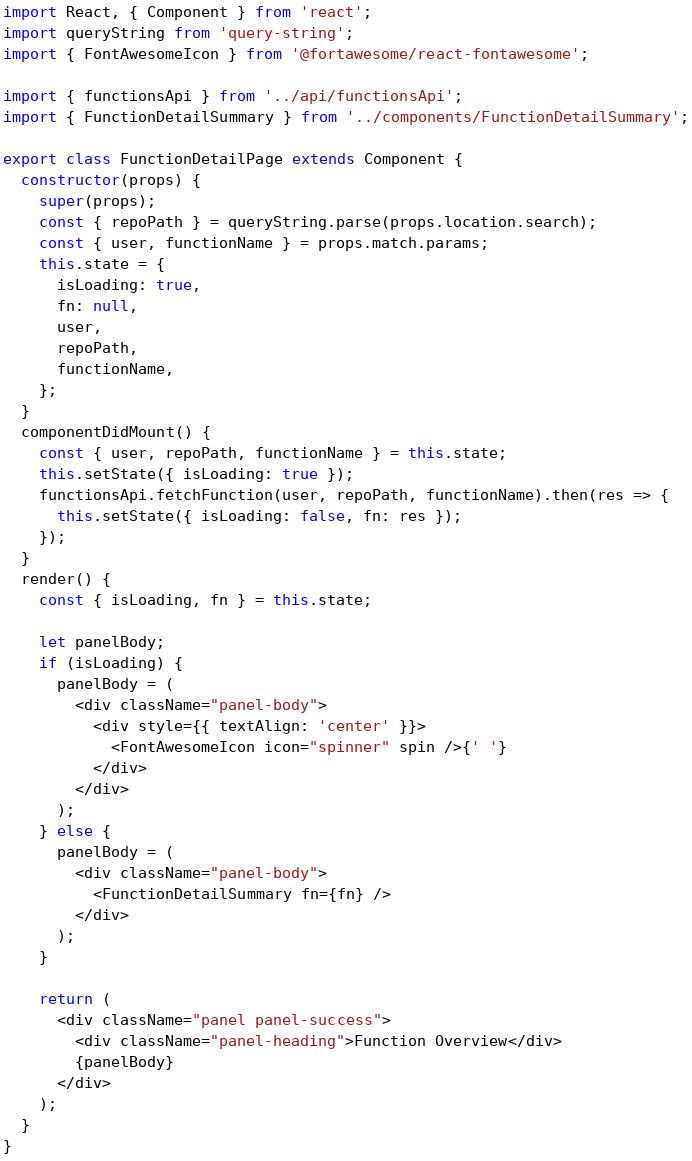<code> <loc_0><loc_0><loc_500><loc_500><_JavaScript_>import React, { Component } from 'react';
import queryString from 'query-string';
import { FontAwesomeIcon } from '@fortawesome/react-fontawesome';

import { functionsApi } from '../api/functionsApi';
import { FunctionDetailSummary } from '../components/FunctionDetailSummary';

export class FunctionDetailPage extends Component {
  constructor(props) {
    super(props);
    const { repoPath } = queryString.parse(props.location.search);
    const { user, functionName } = props.match.params;
    this.state = {
      isLoading: true,
      fn: null,
      user,
      repoPath,
      functionName,
    };
  }
  componentDidMount() {
    const { user, repoPath, functionName } = this.state;
    this.setState({ isLoading: true });
    functionsApi.fetchFunction(user, repoPath, functionName).then(res => {
      this.setState({ isLoading: false, fn: res });
    });
  }
  render() {
    const { isLoading, fn } = this.state;

    let panelBody;
    if (isLoading) {
      panelBody = (
        <div className="panel-body">
          <div style={{ textAlign: 'center' }}>
            <FontAwesomeIcon icon="spinner" spin />{' '}
          </div>
        </div>
      );
    } else {
      panelBody = (
        <div className="panel-body">
          <FunctionDetailSummary fn={fn} />
        </div>
      );
    }

    return (
      <div className="panel panel-success">
        <div className="panel-heading">Function Overview</div>
        {panelBody}
      </div>
    );
  }
}
</code> 